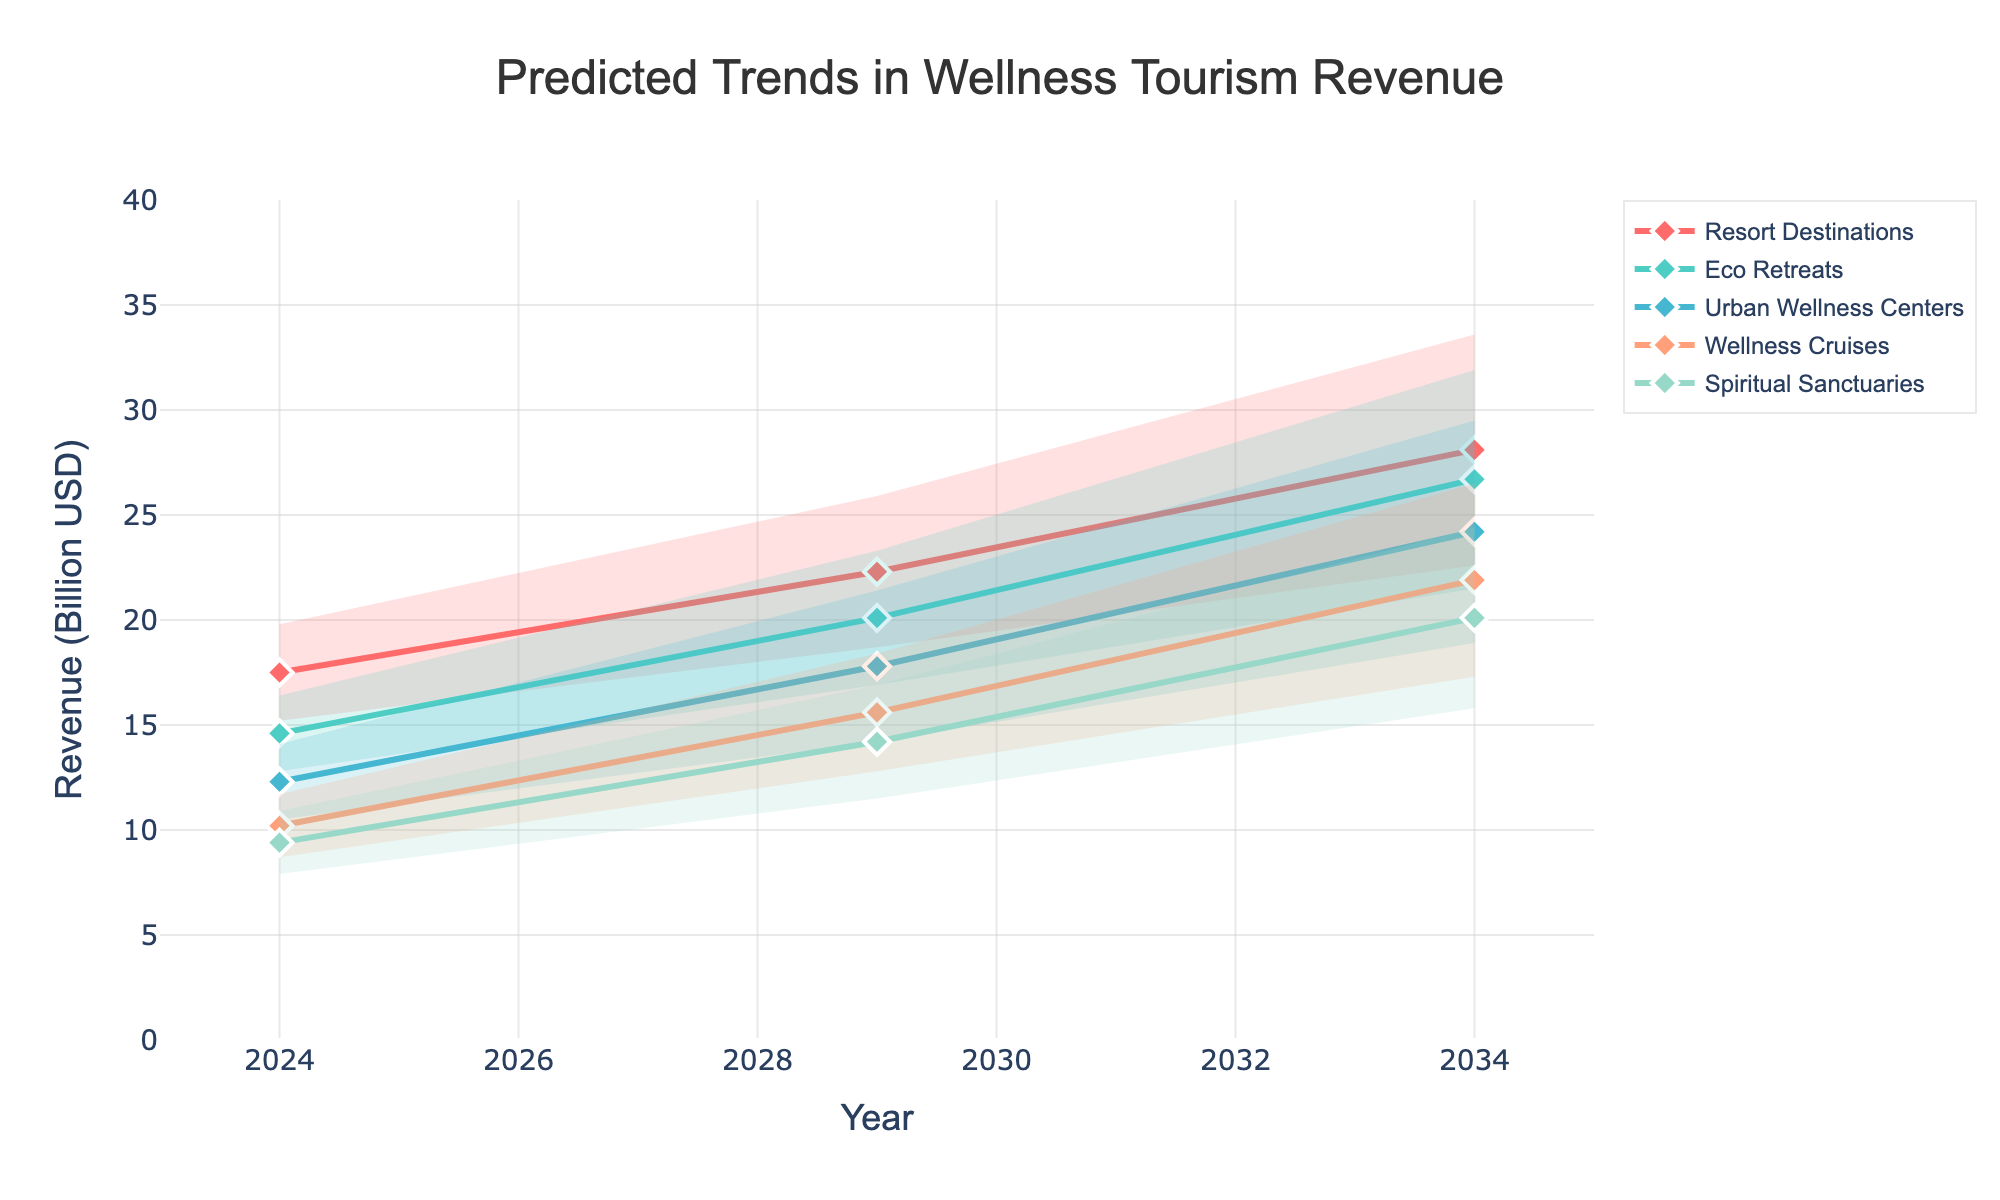what is the title of the chart? The title of the chart can be found at the top center of the image. It provides an overview of the data represented.
Answer: Predicted Trends in Wellness Tourism Revenue what are the five types of destinations shown in the chart? The destination types are labeled in the legend, which usually appears on the right side of the chart.
Answer: Resort Destinations, Eco Retreats, Urban Wellness Centers, Wellness Cruises, Spiritual Sanctuaries Between 2024 and 2034, how much is the medium value projected to increase for Resort Destinations? To find the increase, find the medium values for Resort Destinations in 2024 (17.5) and in 2034 (28.1). Subtract the 2024 value from the 2034 value: 28.1 - 17.5.
Answer: 10.6 Which destination type shows the highest projected revenue in 2034 for the high trend? Locate the high trend values for 2034 and compare them across all destination types.
Answer: Resort Destinations What is the revenue range for Urban Wellness Centers in 2029? For Urban Wellness Centers in 2029, the low value is 14.2 and the high value is 21.4. Subtract the low from the high: 21.4 - 14.2.
Answer: 7.2 How does the revenue projection for Eco Retreats in 2024 medium trend compare to Spiritual Sanctuaries in the same year and trend? Find the years 2024 and trend medium for Eco Retreats (14.6) and Spiritual Sanctuaries (9.4). Compare the two values by subtracting the Spiritual Sanctuaries value from the Eco Retreats value.
Answer: 5.2 Which destination type shows the smallest increase in revenue from 2024 to 2029 in the low trend? Compare the increase from 2024 to 2029 in the low trend across all destination types. Find the smallest difference.
Answer: Urban Wellness Centers (3.7) 